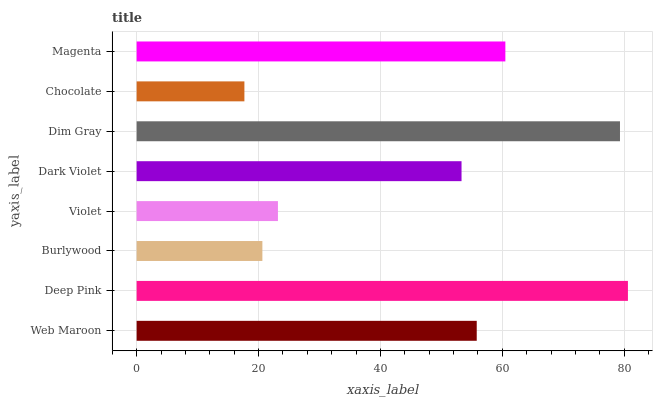Is Chocolate the minimum?
Answer yes or no. Yes. Is Deep Pink the maximum?
Answer yes or no. Yes. Is Burlywood the minimum?
Answer yes or no. No. Is Burlywood the maximum?
Answer yes or no. No. Is Deep Pink greater than Burlywood?
Answer yes or no. Yes. Is Burlywood less than Deep Pink?
Answer yes or no. Yes. Is Burlywood greater than Deep Pink?
Answer yes or no. No. Is Deep Pink less than Burlywood?
Answer yes or no. No. Is Web Maroon the high median?
Answer yes or no. Yes. Is Dark Violet the low median?
Answer yes or no. Yes. Is Dim Gray the high median?
Answer yes or no. No. Is Magenta the low median?
Answer yes or no. No. 